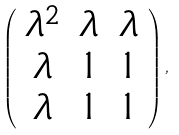<formula> <loc_0><loc_0><loc_500><loc_500>\left ( \begin{array} { c c c } \lambda ^ { 2 } & \lambda & \lambda \\ \lambda & 1 & 1 \\ \lambda & 1 & 1 \end{array} \right ) ,</formula> 